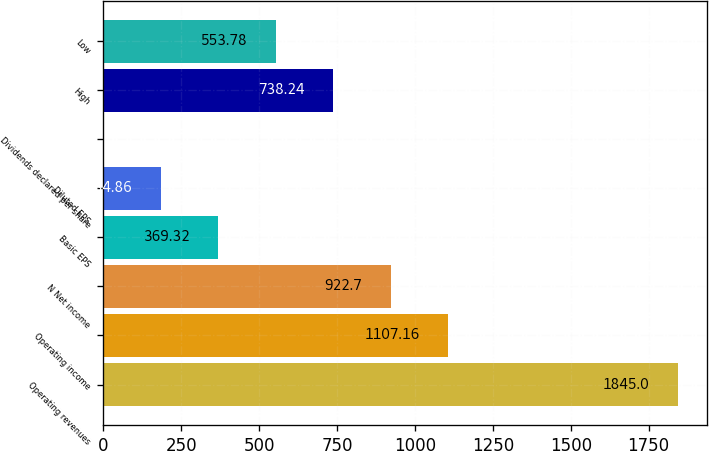Convert chart. <chart><loc_0><loc_0><loc_500><loc_500><bar_chart><fcel>Operating revenues<fcel>Operating income<fcel>N Net income<fcel>Basic EPS<fcel>Diluted EPS<fcel>Dividends declared per share<fcel>High<fcel>Low<nl><fcel>1845<fcel>1107.16<fcel>922.7<fcel>369.32<fcel>184.86<fcel>0.4<fcel>738.24<fcel>553.78<nl></chart> 